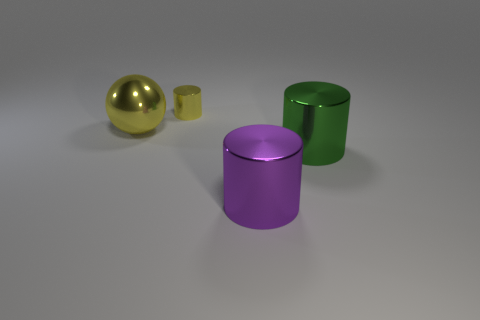Are there any other things that are the same size as the yellow shiny cylinder?
Your response must be concise. No. There is a metallic object on the right side of the big purple cylinder; is its size the same as the yellow shiny sphere behind the purple object?
Offer a terse response. Yes. Is there a yellow cylinder made of the same material as the yellow sphere?
Your answer should be compact. Yes. The cylinder that is the same color as the big metallic ball is what size?
Your answer should be very brief. Small. Is there a big purple metallic cylinder that is in front of the cylinder that is behind the big yellow metallic thing behind the purple thing?
Your response must be concise. Yes. There is a small yellow metal object; are there any things on the right side of it?
Your response must be concise. Yes. How many yellow cylinders are in front of the metal thing that is left of the tiny shiny cylinder?
Provide a short and direct response. 0. Does the yellow ball have the same size as the metallic thing that is right of the purple metallic cylinder?
Keep it short and to the point. Yes. Are there any other tiny cylinders of the same color as the small shiny cylinder?
Make the answer very short. No. What is the size of the yellow cylinder that is made of the same material as the green thing?
Your answer should be very brief. Small. 